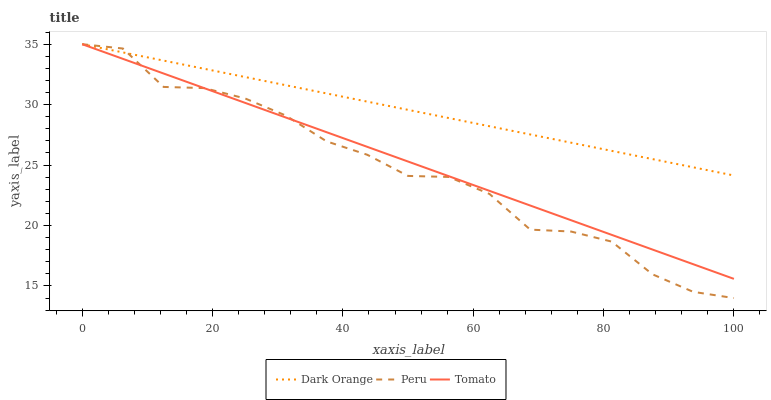Does Peru have the minimum area under the curve?
Answer yes or no. Yes. Does Dark Orange have the maximum area under the curve?
Answer yes or no. Yes. Does Dark Orange have the minimum area under the curve?
Answer yes or no. No. Does Peru have the maximum area under the curve?
Answer yes or no. No. Is Tomato the smoothest?
Answer yes or no. Yes. Is Peru the roughest?
Answer yes or no. Yes. Is Dark Orange the smoothest?
Answer yes or no. No. Is Dark Orange the roughest?
Answer yes or no. No. Does Peru have the lowest value?
Answer yes or no. Yes. Does Dark Orange have the lowest value?
Answer yes or no. No. Does Peru have the highest value?
Answer yes or no. Yes. Does Peru intersect Dark Orange?
Answer yes or no. Yes. Is Peru less than Dark Orange?
Answer yes or no. No. Is Peru greater than Dark Orange?
Answer yes or no. No. 